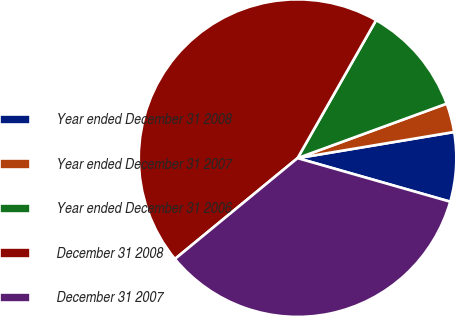Convert chart. <chart><loc_0><loc_0><loc_500><loc_500><pie_chart><fcel>Year ended December 31 2008<fcel>Year ended December 31 2007<fcel>Year ended December 31 2006<fcel>December 31 2008<fcel>December 31 2007<nl><fcel>7.06%<fcel>2.94%<fcel>11.19%<fcel>44.19%<fcel>34.62%<nl></chart> 